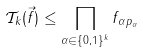Convert formula to latex. <formula><loc_0><loc_0><loc_500><loc_500>\mathcal { T } _ { k } ( \vec { f } ) \leq \prod _ { \alpha \in \{ 0 , 1 \} ^ { k } } \| f _ { \alpha } \| _ { p _ { \alpha } }</formula> 